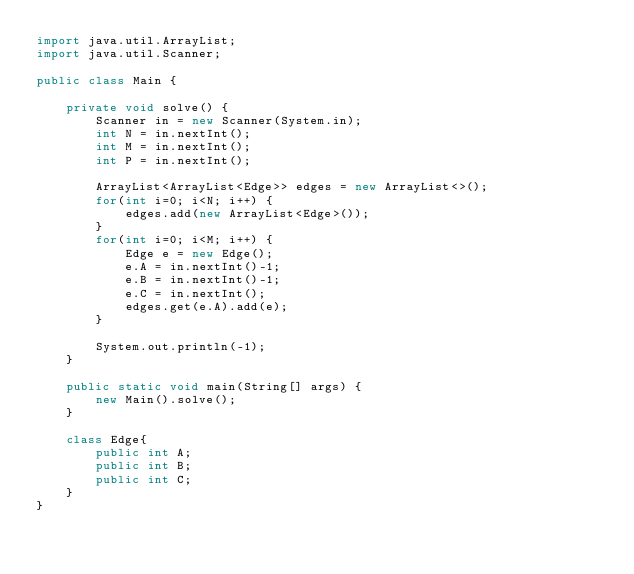Convert code to text. <code><loc_0><loc_0><loc_500><loc_500><_Java_>import java.util.ArrayList;
import java.util.Scanner;

public class Main {

	private void solve() {
		Scanner in = new Scanner(System.in);
		int N = in.nextInt();
		int M = in.nextInt();
		int P = in.nextInt();
		
		ArrayList<ArrayList<Edge>> edges = new ArrayList<>();
		for(int i=0; i<N; i++) {
			edges.add(new ArrayList<Edge>());
		}
		for(int i=0; i<M; i++) {
			Edge e = new Edge();
			e.A = in.nextInt()-1;
			e.B = in.nextInt()-1;
			e.C = in.nextInt();
			edges.get(e.A).add(e);
		}
		
		System.out.println(-1);
	}
	
	public static void main(String[] args) {
		new Main().solve();
	}
	
	class Edge{
		public int A;
		public int B;
		public int C;
	}
}</code> 